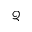Convert formula to latex. <formula><loc_0><loc_0><loc_500><loc_500>\mathcal { Q }</formula> 